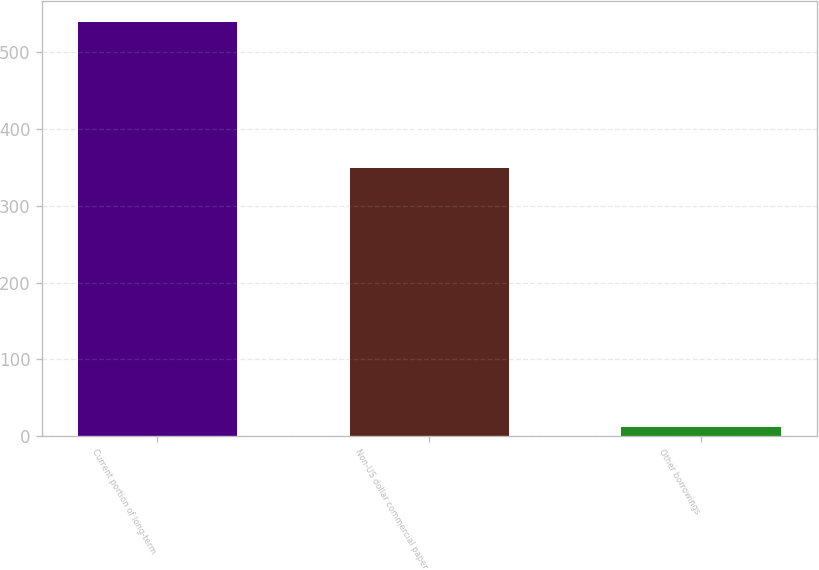Convert chart to OTSL. <chart><loc_0><loc_0><loc_500><loc_500><bar_chart><fcel>Current portion of long-term<fcel>Non-US dollar commercial paper<fcel>Other borrowings<nl><fcel>540<fcel>349<fcel>12<nl></chart> 